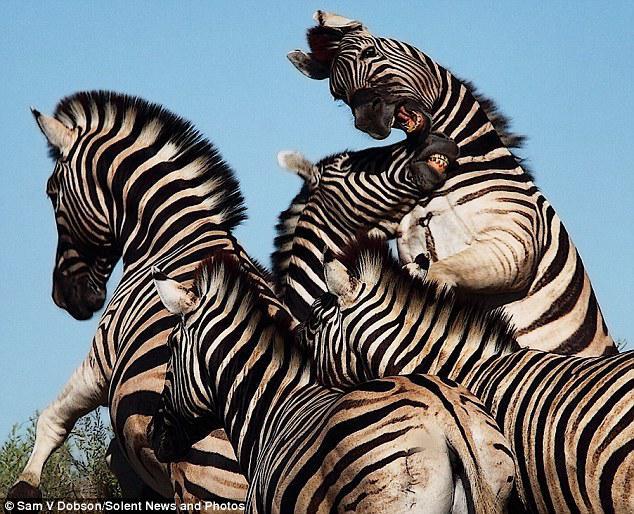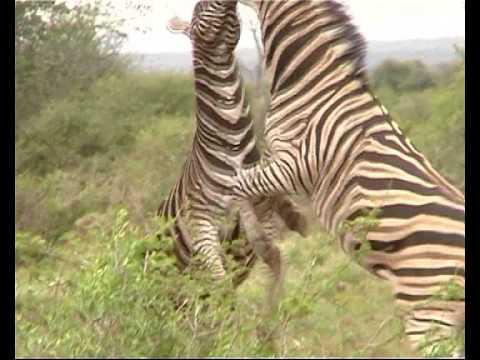The first image is the image on the left, the second image is the image on the right. Assess this claim about the two images: "Both images show zebras fighting, though one has only two zebras and the other image has more.". Correct or not? Answer yes or no. Yes. The first image is the image on the left, the second image is the image on the right. Examine the images to the left and right. Is the description "In exactly one of the images there is at least one zebra with its front legs off the ground." accurate? Answer yes or no. No. 